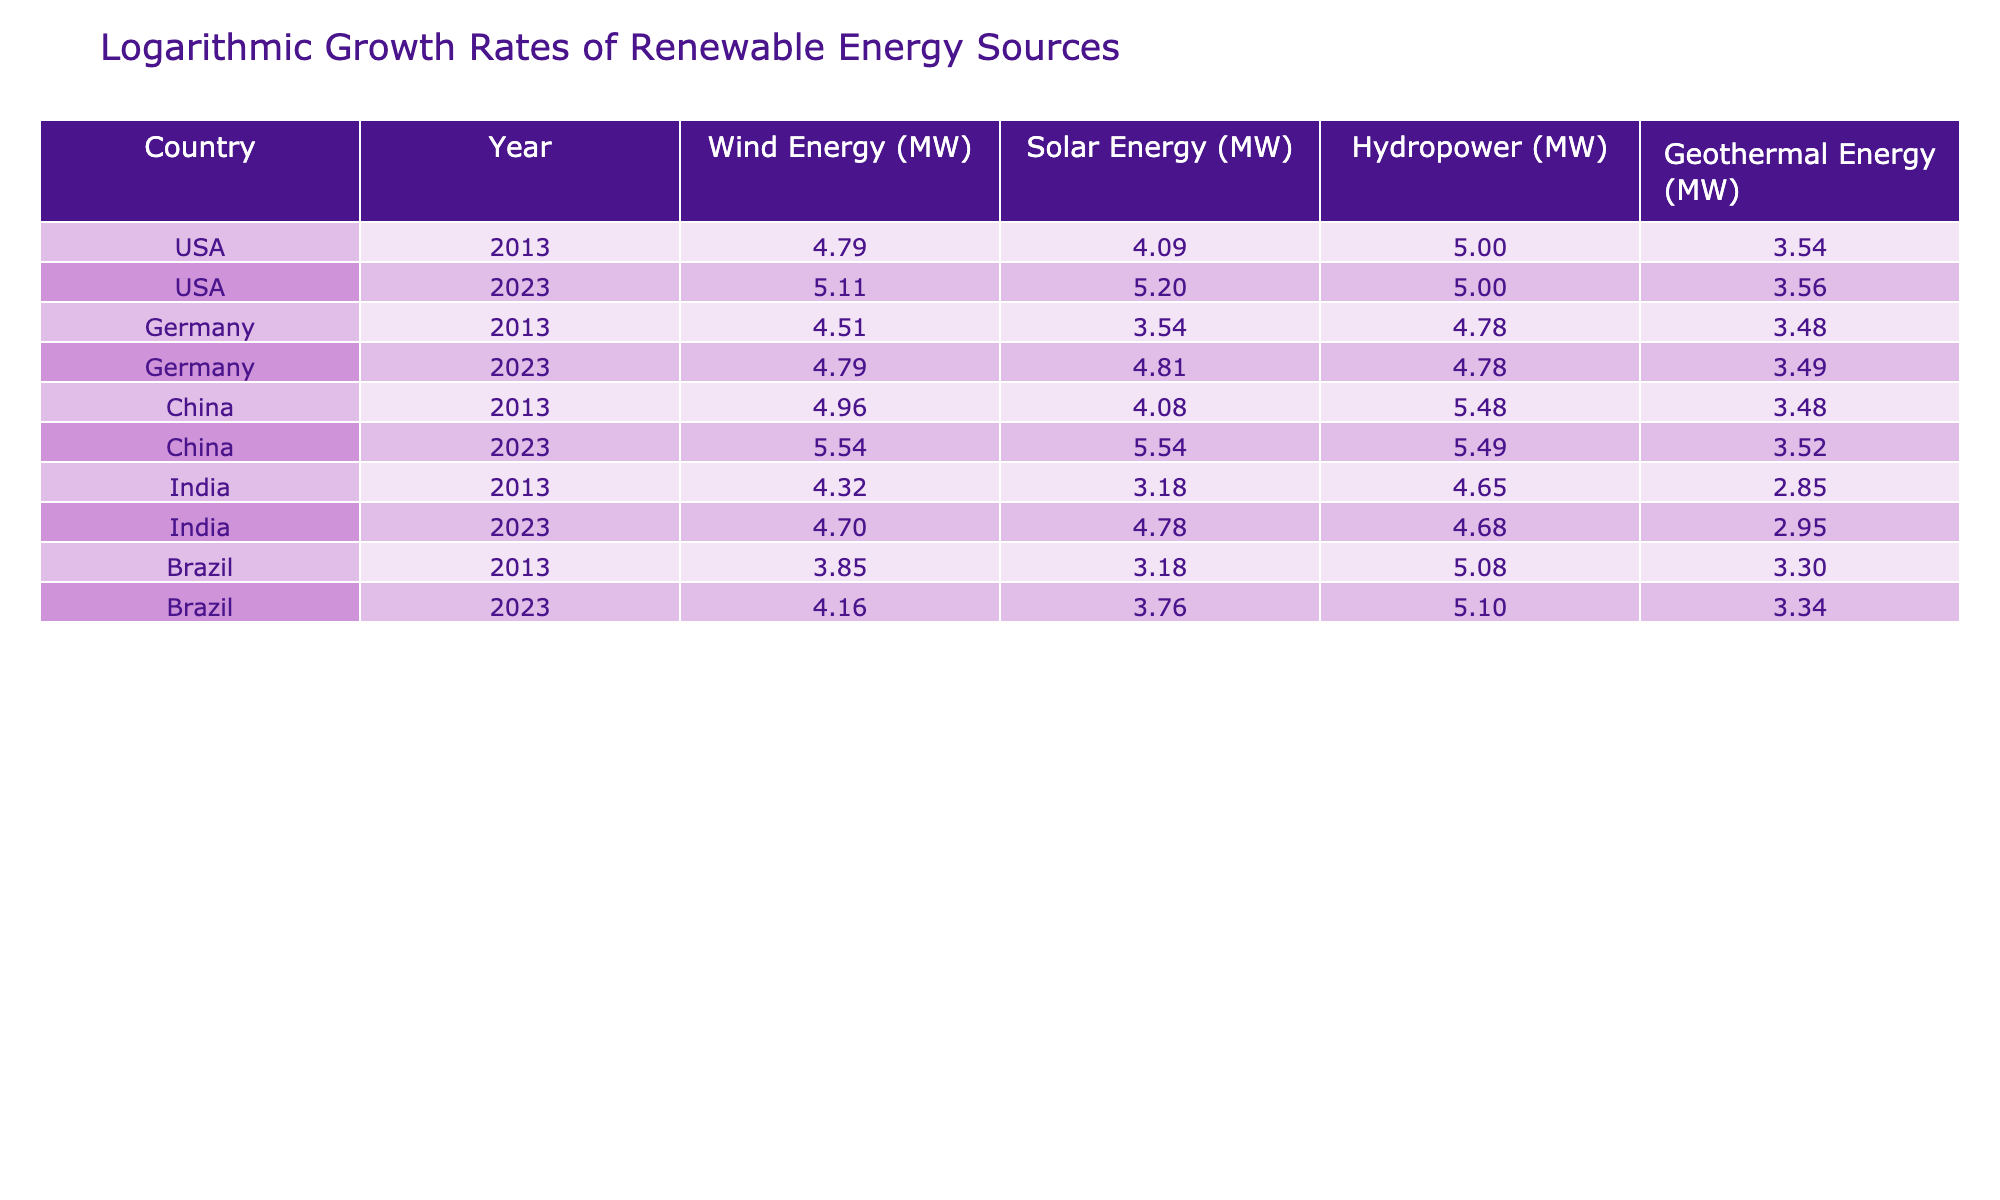What is the logarithmic value of Wind Energy in China in 2023? From the table, I locate the entry for China in the year 2023, under the Wind Energy column, which shows a value of 350000 MW. The logarithmic conversion of this value is log10(350000) ≈ 5.544.
Answer: 5.544 How does the logarithmic value of Solar Energy in Germany in 2023 compare to that in 2013? The table shows Solar Energy for Germany in 2013 as 3500 MW and in 2023 as 65000 MW. Logarithmic values are log10(3500) ≈ 3.544 and log10(65000) ≈ 4.813. The difference is 4.813 - 3.544 = 1.269.
Answer: 1.269 Is the logarithmic value of Solar Energy in India higher than that in Germany in 2023? The logarithmic value for Solar Energy in India in 2023 is log10(60000) ≈ 4.778 and for Germany is log10(65000) ≈ 4.813. Since 4.778 < 4.813, the statement is false.
Answer: No What was the total logarithmic value of Wind and Solar Energy in the USA in 2023? The table provides the values for Wind and Solar Energy in the USA for 2023 as 130000 MW and 160000 MW respectively. The logarithmic values are log10(130000) ≈ 5.113 and log10(160000) ≈ 5.206. The total is 5.113 + 5.206 = 10.319.
Answer: 10.319 Which country had the highest logarithmic value of Hydropower in 2023, and what was that value? Upon checking the 2023 data, China's Hydropower value is 310000 MW. The logarithmic conversion gives log10(310000) ≈ 5.491, which is higher than the others since USA, Germany, India, and Brazil show lower values.
Answer: China, 5.491 What has been the growth in logarithmic values of Geothermal Energy in India from 2013 to 2023? The Geothermal Energy for India in 2013 is 700 MW, with log10(700) ≈ 2.845, and in 2023 it is 900 MW, with log10(900) ≈ 2.954. The growth in logarithmic value is 2.954 - 2.845 = 0.109.
Answer: 0.109 